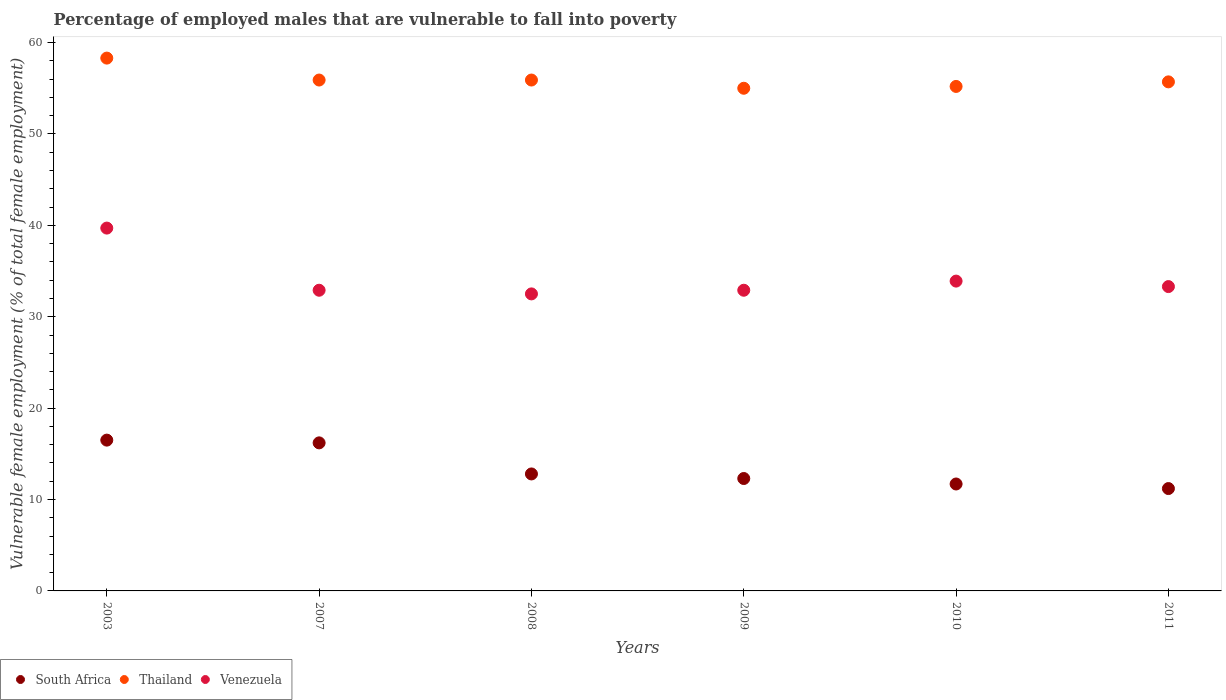Is the number of dotlines equal to the number of legend labels?
Offer a terse response. Yes. What is the percentage of employed males who are vulnerable to fall into poverty in Venezuela in 2003?
Your response must be concise. 39.7. Across all years, what is the maximum percentage of employed males who are vulnerable to fall into poverty in Venezuela?
Give a very brief answer. 39.7. Across all years, what is the minimum percentage of employed males who are vulnerable to fall into poverty in South Africa?
Provide a succinct answer. 11.2. What is the total percentage of employed males who are vulnerable to fall into poverty in South Africa in the graph?
Keep it short and to the point. 80.7. What is the difference between the percentage of employed males who are vulnerable to fall into poverty in Venezuela in 2003 and that in 2011?
Your answer should be compact. 6.4. What is the difference between the percentage of employed males who are vulnerable to fall into poverty in South Africa in 2007 and the percentage of employed males who are vulnerable to fall into poverty in Thailand in 2010?
Offer a terse response. -39. What is the average percentage of employed males who are vulnerable to fall into poverty in South Africa per year?
Make the answer very short. 13.45. In the year 2003, what is the difference between the percentage of employed males who are vulnerable to fall into poverty in Thailand and percentage of employed males who are vulnerable to fall into poverty in South Africa?
Make the answer very short. 41.8. In how many years, is the percentage of employed males who are vulnerable to fall into poverty in South Africa greater than 10 %?
Keep it short and to the point. 6. What is the ratio of the percentage of employed males who are vulnerable to fall into poverty in South Africa in 2009 to that in 2011?
Keep it short and to the point. 1.1. Is the difference between the percentage of employed males who are vulnerable to fall into poverty in Thailand in 2003 and 2009 greater than the difference between the percentage of employed males who are vulnerable to fall into poverty in South Africa in 2003 and 2009?
Your answer should be very brief. No. What is the difference between the highest and the second highest percentage of employed males who are vulnerable to fall into poverty in South Africa?
Your response must be concise. 0.3. What is the difference between the highest and the lowest percentage of employed males who are vulnerable to fall into poverty in Thailand?
Your answer should be compact. 3.3. Is it the case that in every year, the sum of the percentage of employed males who are vulnerable to fall into poverty in Venezuela and percentage of employed males who are vulnerable to fall into poverty in Thailand  is greater than the percentage of employed males who are vulnerable to fall into poverty in South Africa?
Your response must be concise. Yes. Does the percentage of employed males who are vulnerable to fall into poverty in Thailand monotonically increase over the years?
Keep it short and to the point. No. Is the percentage of employed males who are vulnerable to fall into poverty in Venezuela strictly less than the percentage of employed males who are vulnerable to fall into poverty in South Africa over the years?
Your response must be concise. No. How many dotlines are there?
Your answer should be very brief. 3. How many years are there in the graph?
Your response must be concise. 6. Are the values on the major ticks of Y-axis written in scientific E-notation?
Provide a succinct answer. No. Does the graph contain any zero values?
Make the answer very short. No. How many legend labels are there?
Your answer should be compact. 3. What is the title of the graph?
Make the answer very short. Percentage of employed males that are vulnerable to fall into poverty. What is the label or title of the Y-axis?
Provide a short and direct response. Vulnerable female employment (% of total female employment). What is the Vulnerable female employment (% of total female employment) of South Africa in 2003?
Offer a terse response. 16.5. What is the Vulnerable female employment (% of total female employment) of Thailand in 2003?
Offer a very short reply. 58.3. What is the Vulnerable female employment (% of total female employment) of Venezuela in 2003?
Your response must be concise. 39.7. What is the Vulnerable female employment (% of total female employment) of South Africa in 2007?
Your response must be concise. 16.2. What is the Vulnerable female employment (% of total female employment) of Thailand in 2007?
Your answer should be very brief. 55.9. What is the Vulnerable female employment (% of total female employment) in Venezuela in 2007?
Give a very brief answer. 32.9. What is the Vulnerable female employment (% of total female employment) of South Africa in 2008?
Your answer should be very brief. 12.8. What is the Vulnerable female employment (% of total female employment) in Thailand in 2008?
Ensure brevity in your answer.  55.9. What is the Vulnerable female employment (% of total female employment) in Venezuela in 2008?
Give a very brief answer. 32.5. What is the Vulnerable female employment (% of total female employment) of South Africa in 2009?
Offer a very short reply. 12.3. What is the Vulnerable female employment (% of total female employment) of Thailand in 2009?
Your response must be concise. 55. What is the Vulnerable female employment (% of total female employment) in Venezuela in 2009?
Provide a succinct answer. 32.9. What is the Vulnerable female employment (% of total female employment) in South Africa in 2010?
Offer a terse response. 11.7. What is the Vulnerable female employment (% of total female employment) in Thailand in 2010?
Make the answer very short. 55.2. What is the Vulnerable female employment (% of total female employment) in Venezuela in 2010?
Offer a terse response. 33.9. What is the Vulnerable female employment (% of total female employment) of South Africa in 2011?
Offer a terse response. 11.2. What is the Vulnerable female employment (% of total female employment) of Thailand in 2011?
Your answer should be compact. 55.7. What is the Vulnerable female employment (% of total female employment) of Venezuela in 2011?
Give a very brief answer. 33.3. Across all years, what is the maximum Vulnerable female employment (% of total female employment) in South Africa?
Give a very brief answer. 16.5. Across all years, what is the maximum Vulnerable female employment (% of total female employment) of Thailand?
Give a very brief answer. 58.3. Across all years, what is the maximum Vulnerable female employment (% of total female employment) of Venezuela?
Provide a succinct answer. 39.7. Across all years, what is the minimum Vulnerable female employment (% of total female employment) in South Africa?
Provide a short and direct response. 11.2. Across all years, what is the minimum Vulnerable female employment (% of total female employment) of Venezuela?
Your response must be concise. 32.5. What is the total Vulnerable female employment (% of total female employment) in South Africa in the graph?
Offer a very short reply. 80.7. What is the total Vulnerable female employment (% of total female employment) of Thailand in the graph?
Ensure brevity in your answer.  336. What is the total Vulnerable female employment (% of total female employment) in Venezuela in the graph?
Offer a very short reply. 205.2. What is the difference between the Vulnerable female employment (% of total female employment) in South Africa in 2003 and that in 2007?
Your answer should be very brief. 0.3. What is the difference between the Vulnerable female employment (% of total female employment) in South Africa in 2003 and that in 2008?
Ensure brevity in your answer.  3.7. What is the difference between the Vulnerable female employment (% of total female employment) in Thailand in 2003 and that in 2008?
Give a very brief answer. 2.4. What is the difference between the Vulnerable female employment (% of total female employment) of Venezuela in 2003 and that in 2008?
Make the answer very short. 7.2. What is the difference between the Vulnerable female employment (% of total female employment) of South Africa in 2003 and that in 2009?
Your answer should be compact. 4.2. What is the difference between the Vulnerable female employment (% of total female employment) in Thailand in 2003 and that in 2009?
Offer a terse response. 3.3. What is the difference between the Vulnerable female employment (% of total female employment) of South Africa in 2003 and that in 2010?
Provide a succinct answer. 4.8. What is the difference between the Vulnerable female employment (% of total female employment) of Thailand in 2003 and that in 2010?
Your answer should be very brief. 3.1. What is the difference between the Vulnerable female employment (% of total female employment) in Thailand in 2003 and that in 2011?
Your answer should be compact. 2.6. What is the difference between the Vulnerable female employment (% of total female employment) in Thailand in 2007 and that in 2008?
Your answer should be very brief. 0. What is the difference between the Vulnerable female employment (% of total female employment) of Venezuela in 2007 and that in 2009?
Make the answer very short. 0. What is the difference between the Vulnerable female employment (% of total female employment) of South Africa in 2007 and that in 2010?
Your answer should be compact. 4.5. What is the difference between the Vulnerable female employment (% of total female employment) of Thailand in 2007 and that in 2010?
Your answer should be compact. 0.7. What is the difference between the Vulnerable female employment (% of total female employment) of Venezuela in 2007 and that in 2011?
Provide a short and direct response. -0.4. What is the difference between the Vulnerable female employment (% of total female employment) of Thailand in 2008 and that in 2009?
Your response must be concise. 0.9. What is the difference between the Vulnerable female employment (% of total female employment) of Venezuela in 2008 and that in 2009?
Offer a terse response. -0.4. What is the difference between the Vulnerable female employment (% of total female employment) of South Africa in 2008 and that in 2010?
Offer a very short reply. 1.1. What is the difference between the Vulnerable female employment (% of total female employment) of Thailand in 2008 and that in 2011?
Give a very brief answer. 0.2. What is the difference between the Vulnerable female employment (% of total female employment) in Venezuela in 2008 and that in 2011?
Ensure brevity in your answer.  -0.8. What is the difference between the Vulnerable female employment (% of total female employment) in Thailand in 2009 and that in 2010?
Keep it short and to the point. -0.2. What is the difference between the Vulnerable female employment (% of total female employment) of South Africa in 2009 and that in 2011?
Provide a short and direct response. 1.1. What is the difference between the Vulnerable female employment (% of total female employment) in Venezuela in 2010 and that in 2011?
Provide a succinct answer. 0.6. What is the difference between the Vulnerable female employment (% of total female employment) of South Africa in 2003 and the Vulnerable female employment (% of total female employment) of Thailand in 2007?
Make the answer very short. -39.4. What is the difference between the Vulnerable female employment (% of total female employment) in South Africa in 2003 and the Vulnerable female employment (% of total female employment) in Venezuela in 2007?
Make the answer very short. -16.4. What is the difference between the Vulnerable female employment (% of total female employment) in Thailand in 2003 and the Vulnerable female employment (% of total female employment) in Venezuela in 2007?
Give a very brief answer. 25.4. What is the difference between the Vulnerable female employment (% of total female employment) in South Africa in 2003 and the Vulnerable female employment (% of total female employment) in Thailand in 2008?
Keep it short and to the point. -39.4. What is the difference between the Vulnerable female employment (% of total female employment) in South Africa in 2003 and the Vulnerable female employment (% of total female employment) in Venezuela in 2008?
Offer a very short reply. -16. What is the difference between the Vulnerable female employment (% of total female employment) in Thailand in 2003 and the Vulnerable female employment (% of total female employment) in Venezuela in 2008?
Your answer should be compact. 25.8. What is the difference between the Vulnerable female employment (% of total female employment) in South Africa in 2003 and the Vulnerable female employment (% of total female employment) in Thailand in 2009?
Offer a very short reply. -38.5. What is the difference between the Vulnerable female employment (% of total female employment) of South Africa in 2003 and the Vulnerable female employment (% of total female employment) of Venezuela in 2009?
Your response must be concise. -16.4. What is the difference between the Vulnerable female employment (% of total female employment) in Thailand in 2003 and the Vulnerable female employment (% of total female employment) in Venezuela in 2009?
Provide a succinct answer. 25.4. What is the difference between the Vulnerable female employment (% of total female employment) of South Africa in 2003 and the Vulnerable female employment (% of total female employment) of Thailand in 2010?
Your answer should be compact. -38.7. What is the difference between the Vulnerable female employment (% of total female employment) of South Africa in 2003 and the Vulnerable female employment (% of total female employment) of Venezuela in 2010?
Provide a succinct answer. -17.4. What is the difference between the Vulnerable female employment (% of total female employment) of Thailand in 2003 and the Vulnerable female employment (% of total female employment) of Venezuela in 2010?
Give a very brief answer. 24.4. What is the difference between the Vulnerable female employment (% of total female employment) in South Africa in 2003 and the Vulnerable female employment (% of total female employment) in Thailand in 2011?
Your answer should be very brief. -39.2. What is the difference between the Vulnerable female employment (% of total female employment) in South Africa in 2003 and the Vulnerable female employment (% of total female employment) in Venezuela in 2011?
Ensure brevity in your answer.  -16.8. What is the difference between the Vulnerable female employment (% of total female employment) in Thailand in 2003 and the Vulnerable female employment (% of total female employment) in Venezuela in 2011?
Give a very brief answer. 25. What is the difference between the Vulnerable female employment (% of total female employment) in South Africa in 2007 and the Vulnerable female employment (% of total female employment) in Thailand in 2008?
Provide a short and direct response. -39.7. What is the difference between the Vulnerable female employment (% of total female employment) of South Africa in 2007 and the Vulnerable female employment (% of total female employment) of Venezuela in 2008?
Offer a terse response. -16.3. What is the difference between the Vulnerable female employment (% of total female employment) of Thailand in 2007 and the Vulnerable female employment (% of total female employment) of Venezuela in 2008?
Offer a terse response. 23.4. What is the difference between the Vulnerable female employment (% of total female employment) in South Africa in 2007 and the Vulnerable female employment (% of total female employment) in Thailand in 2009?
Offer a very short reply. -38.8. What is the difference between the Vulnerable female employment (% of total female employment) of South Africa in 2007 and the Vulnerable female employment (% of total female employment) of Venezuela in 2009?
Your answer should be very brief. -16.7. What is the difference between the Vulnerable female employment (% of total female employment) of South Africa in 2007 and the Vulnerable female employment (% of total female employment) of Thailand in 2010?
Offer a terse response. -39. What is the difference between the Vulnerable female employment (% of total female employment) of South Africa in 2007 and the Vulnerable female employment (% of total female employment) of Venezuela in 2010?
Give a very brief answer. -17.7. What is the difference between the Vulnerable female employment (% of total female employment) of South Africa in 2007 and the Vulnerable female employment (% of total female employment) of Thailand in 2011?
Your answer should be very brief. -39.5. What is the difference between the Vulnerable female employment (% of total female employment) in South Africa in 2007 and the Vulnerable female employment (% of total female employment) in Venezuela in 2011?
Your answer should be compact. -17.1. What is the difference between the Vulnerable female employment (% of total female employment) in Thailand in 2007 and the Vulnerable female employment (% of total female employment) in Venezuela in 2011?
Your response must be concise. 22.6. What is the difference between the Vulnerable female employment (% of total female employment) in South Africa in 2008 and the Vulnerable female employment (% of total female employment) in Thailand in 2009?
Offer a very short reply. -42.2. What is the difference between the Vulnerable female employment (% of total female employment) of South Africa in 2008 and the Vulnerable female employment (% of total female employment) of Venezuela in 2009?
Your answer should be very brief. -20.1. What is the difference between the Vulnerable female employment (% of total female employment) of Thailand in 2008 and the Vulnerable female employment (% of total female employment) of Venezuela in 2009?
Ensure brevity in your answer.  23. What is the difference between the Vulnerable female employment (% of total female employment) of South Africa in 2008 and the Vulnerable female employment (% of total female employment) of Thailand in 2010?
Make the answer very short. -42.4. What is the difference between the Vulnerable female employment (% of total female employment) in South Africa in 2008 and the Vulnerable female employment (% of total female employment) in Venezuela in 2010?
Provide a short and direct response. -21.1. What is the difference between the Vulnerable female employment (% of total female employment) in South Africa in 2008 and the Vulnerable female employment (% of total female employment) in Thailand in 2011?
Provide a short and direct response. -42.9. What is the difference between the Vulnerable female employment (% of total female employment) of South Africa in 2008 and the Vulnerable female employment (% of total female employment) of Venezuela in 2011?
Provide a succinct answer. -20.5. What is the difference between the Vulnerable female employment (% of total female employment) of Thailand in 2008 and the Vulnerable female employment (% of total female employment) of Venezuela in 2011?
Provide a succinct answer. 22.6. What is the difference between the Vulnerable female employment (% of total female employment) in South Africa in 2009 and the Vulnerable female employment (% of total female employment) in Thailand in 2010?
Keep it short and to the point. -42.9. What is the difference between the Vulnerable female employment (% of total female employment) of South Africa in 2009 and the Vulnerable female employment (% of total female employment) of Venezuela in 2010?
Provide a short and direct response. -21.6. What is the difference between the Vulnerable female employment (% of total female employment) of Thailand in 2009 and the Vulnerable female employment (% of total female employment) of Venezuela in 2010?
Offer a very short reply. 21.1. What is the difference between the Vulnerable female employment (% of total female employment) in South Africa in 2009 and the Vulnerable female employment (% of total female employment) in Thailand in 2011?
Offer a very short reply. -43.4. What is the difference between the Vulnerable female employment (% of total female employment) in South Africa in 2009 and the Vulnerable female employment (% of total female employment) in Venezuela in 2011?
Give a very brief answer. -21. What is the difference between the Vulnerable female employment (% of total female employment) in Thailand in 2009 and the Vulnerable female employment (% of total female employment) in Venezuela in 2011?
Provide a short and direct response. 21.7. What is the difference between the Vulnerable female employment (% of total female employment) of South Africa in 2010 and the Vulnerable female employment (% of total female employment) of Thailand in 2011?
Make the answer very short. -44. What is the difference between the Vulnerable female employment (% of total female employment) of South Africa in 2010 and the Vulnerable female employment (% of total female employment) of Venezuela in 2011?
Keep it short and to the point. -21.6. What is the difference between the Vulnerable female employment (% of total female employment) in Thailand in 2010 and the Vulnerable female employment (% of total female employment) in Venezuela in 2011?
Ensure brevity in your answer.  21.9. What is the average Vulnerable female employment (% of total female employment) in South Africa per year?
Offer a very short reply. 13.45. What is the average Vulnerable female employment (% of total female employment) in Thailand per year?
Make the answer very short. 56. What is the average Vulnerable female employment (% of total female employment) in Venezuela per year?
Offer a terse response. 34.2. In the year 2003, what is the difference between the Vulnerable female employment (% of total female employment) in South Africa and Vulnerable female employment (% of total female employment) in Thailand?
Offer a terse response. -41.8. In the year 2003, what is the difference between the Vulnerable female employment (% of total female employment) in South Africa and Vulnerable female employment (% of total female employment) in Venezuela?
Your answer should be very brief. -23.2. In the year 2003, what is the difference between the Vulnerable female employment (% of total female employment) of Thailand and Vulnerable female employment (% of total female employment) of Venezuela?
Provide a short and direct response. 18.6. In the year 2007, what is the difference between the Vulnerable female employment (% of total female employment) of South Africa and Vulnerable female employment (% of total female employment) of Thailand?
Your answer should be very brief. -39.7. In the year 2007, what is the difference between the Vulnerable female employment (% of total female employment) of South Africa and Vulnerable female employment (% of total female employment) of Venezuela?
Your response must be concise. -16.7. In the year 2007, what is the difference between the Vulnerable female employment (% of total female employment) of Thailand and Vulnerable female employment (% of total female employment) of Venezuela?
Your answer should be very brief. 23. In the year 2008, what is the difference between the Vulnerable female employment (% of total female employment) in South Africa and Vulnerable female employment (% of total female employment) in Thailand?
Your answer should be very brief. -43.1. In the year 2008, what is the difference between the Vulnerable female employment (% of total female employment) of South Africa and Vulnerable female employment (% of total female employment) of Venezuela?
Ensure brevity in your answer.  -19.7. In the year 2008, what is the difference between the Vulnerable female employment (% of total female employment) of Thailand and Vulnerable female employment (% of total female employment) of Venezuela?
Offer a very short reply. 23.4. In the year 2009, what is the difference between the Vulnerable female employment (% of total female employment) in South Africa and Vulnerable female employment (% of total female employment) in Thailand?
Provide a succinct answer. -42.7. In the year 2009, what is the difference between the Vulnerable female employment (% of total female employment) of South Africa and Vulnerable female employment (% of total female employment) of Venezuela?
Provide a succinct answer. -20.6. In the year 2009, what is the difference between the Vulnerable female employment (% of total female employment) of Thailand and Vulnerable female employment (% of total female employment) of Venezuela?
Offer a very short reply. 22.1. In the year 2010, what is the difference between the Vulnerable female employment (% of total female employment) of South Africa and Vulnerable female employment (% of total female employment) of Thailand?
Provide a short and direct response. -43.5. In the year 2010, what is the difference between the Vulnerable female employment (% of total female employment) of South Africa and Vulnerable female employment (% of total female employment) of Venezuela?
Your answer should be compact. -22.2. In the year 2010, what is the difference between the Vulnerable female employment (% of total female employment) in Thailand and Vulnerable female employment (% of total female employment) in Venezuela?
Offer a terse response. 21.3. In the year 2011, what is the difference between the Vulnerable female employment (% of total female employment) of South Africa and Vulnerable female employment (% of total female employment) of Thailand?
Ensure brevity in your answer.  -44.5. In the year 2011, what is the difference between the Vulnerable female employment (% of total female employment) of South Africa and Vulnerable female employment (% of total female employment) of Venezuela?
Offer a very short reply. -22.1. In the year 2011, what is the difference between the Vulnerable female employment (% of total female employment) of Thailand and Vulnerable female employment (% of total female employment) of Venezuela?
Provide a succinct answer. 22.4. What is the ratio of the Vulnerable female employment (% of total female employment) of South Africa in 2003 to that in 2007?
Provide a succinct answer. 1.02. What is the ratio of the Vulnerable female employment (% of total female employment) of Thailand in 2003 to that in 2007?
Keep it short and to the point. 1.04. What is the ratio of the Vulnerable female employment (% of total female employment) of Venezuela in 2003 to that in 2007?
Ensure brevity in your answer.  1.21. What is the ratio of the Vulnerable female employment (% of total female employment) of South Africa in 2003 to that in 2008?
Offer a very short reply. 1.29. What is the ratio of the Vulnerable female employment (% of total female employment) of Thailand in 2003 to that in 2008?
Provide a short and direct response. 1.04. What is the ratio of the Vulnerable female employment (% of total female employment) in Venezuela in 2003 to that in 2008?
Your answer should be compact. 1.22. What is the ratio of the Vulnerable female employment (% of total female employment) in South Africa in 2003 to that in 2009?
Provide a succinct answer. 1.34. What is the ratio of the Vulnerable female employment (% of total female employment) of Thailand in 2003 to that in 2009?
Provide a short and direct response. 1.06. What is the ratio of the Vulnerable female employment (% of total female employment) in Venezuela in 2003 to that in 2009?
Provide a short and direct response. 1.21. What is the ratio of the Vulnerable female employment (% of total female employment) of South Africa in 2003 to that in 2010?
Make the answer very short. 1.41. What is the ratio of the Vulnerable female employment (% of total female employment) in Thailand in 2003 to that in 2010?
Ensure brevity in your answer.  1.06. What is the ratio of the Vulnerable female employment (% of total female employment) of Venezuela in 2003 to that in 2010?
Offer a very short reply. 1.17. What is the ratio of the Vulnerable female employment (% of total female employment) of South Africa in 2003 to that in 2011?
Ensure brevity in your answer.  1.47. What is the ratio of the Vulnerable female employment (% of total female employment) in Thailand in 2003 to that in 2011?
Ensure brevity in your answer.  1.05. What is the ratio of the Vulnerable female employment (% of total female employment) in Venezuela in 2003 to that in 2011?
Give a very brief answer. 1.19. What is the ratio of the Vulnerable female employment (% of total female employment) of South Africa in 2007 to that in 2008?
Make the answer very short. 1.27. What is the ratio of the Vulnerable female employment (% of total female employment) in Venezuela in 2007 to that in 2008?
Provide a short and direct response. 1.01. What is the ratio of the Vulnerable female employment (% of total female employment) of South Africa in 2007 to that in 2009?
Ensure brevity in your answer.  1.32. What is the ratio of the Vulnerable female employment (% of total female employment) of Thailand in 2007 to that in 2009?
Provide a short and direct response. 1.02. What is the ratio of the Vulnerable female employment (% of total female employment) in Venezuela in 2007 to that in 2009?
Your answer should be compact. 1. What is the ratio of the Vulnerable female employment (% of total female employment) in South Africa in 2007 to that in 2010?
Your answer should be compact. 1.38. What is the ratio of the Vulnerable female employment (% of total female employment) in Thailand in 2007 to that in 2010?
Give a very brief answer. 1.01. What is the ratio of the Vulnerable female employment (% of total female employment) in Venezuela in 2007 to that in 2010?
Provide a succinct answer. 0.97. What is the ratio of the Vulnerable female employment (% of total female employment) in South Africa in 2007 to that in 2011?
Offer a terse response. 1.45. What is the ratio of the Vulnerable female employment (% of total female employment) in Thailand in 2007 to that in 2011?
Keep it short and to the point. 1. What is the ratio of the Vulnerable female employment (% of total female employment) in Venezuela in 2007 to that in 2011?
Your response must be concise. 0.99. What is the ratio of the Vulnerable female employment (% of total female employment) in South Africa in 2008 to that in 2009?
Your response must be concise. 1.04. What is the ratio of the Vulnerable female employment (% of total female employment) in Thailand in 2008 to that in 2009?
Provide a succinct answer. 1.02. What is the ratio of the Vulnerable female employment (% of total female employment) of South Africa in 2008 to that in 2010?
Provide a succinct answer. 1.09. What is the ratio of the Vulnerable female employment (% of total female employment) in Thailand in 2008 to that in 2010?
Offer a very short reply. 1.01. What is the ratio of the Vulnerable female employment (% of total female employment) in Venezuela in 2008 to that in 2010?
Offer a terse response. 0.96. What is the ratio of the Vulnerable female employment (% of total female employment) of South Africa in 2008 to that in 2011?
Your answer should be very brief. 1.14. What is the ratio of the Vulnerable female employment (% of total female employment) in Venezuela in 2008 to that in 2011?
Ensure brevity in your answer.  0.98. What is the ratio of the Vulnerable female employment (% of total female employment) of South Africa in 2009 to that in 2010?
Your answer should be very brief. 1.05. What is the ratio of the Vulnerable female employment (% of total female employment) of Venezuela in 2009 to that in 2010?
Your answer should be compact. 0.97. What is the ratio of the Vulnerable female employment (% of total female employment) in South Africa in 2009 to that in 2011?
Your answer should be compact. 1.1. What is the ratio of the Vulnerable female employment (% of total female employment) of Thailand in 2009 to that in 2011?
Your answer should be compact. 0.99. What is the ratio of the Vulnerable female employment (% of total female employment) of Venezuela in 2009 to that in 2011?
Ensure brevity in your answer.  0.99. What is the ratio of the Vulnerable female employment (% of total female employment) of South Africa in 2010 to that in 2011?
Provide a succinct answer. 1.04. What is the ratio of the Vulnerable female employment (% of total female employment) in Thailand in 2010 to that in 2011?
Provide a short and direct response. 0.99. What is the ratio of the Vulnerable female employment (% of total female employment) in Venezuela in 2010 to that in 2011?
Keep it short and to the point. 1.02. What is the difference between the highest and the lowest Vulnerable female employment (% of total female employment) in South Africa?
Give a very brief answer. 5.3. 